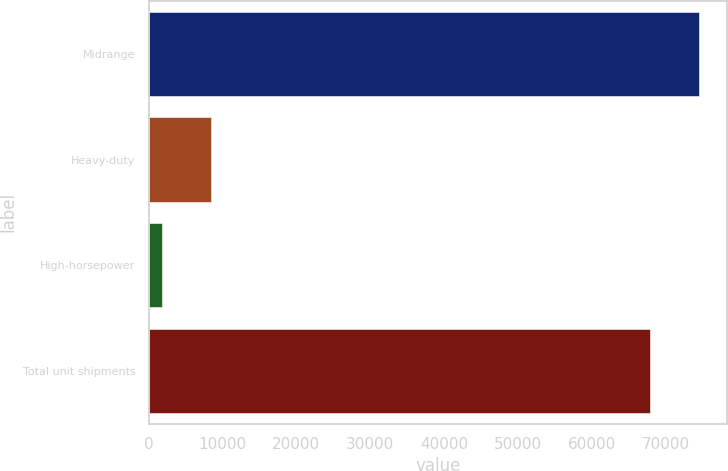<chart> <loc_0><loc_0><loc_500><loc_500><bar_chart><fcel>Midrange<fcel>Heavy-duty<fcel>High-horsepower<fcel>Total unit shipments<nl><fcel>74610<fcel>8510<fcel>1800<fcel>67900<nl></chart> 